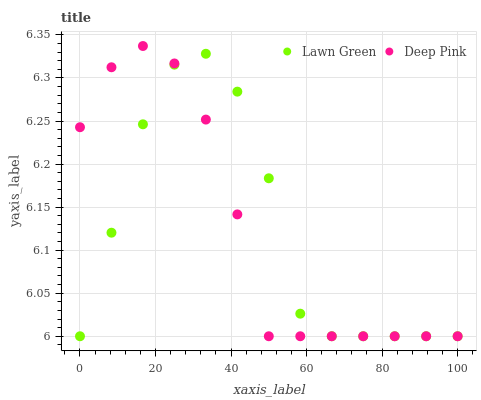Does Deep Pink have the minimum area under the curve?
Answer yes or no. Yes. Does Lawn Green have the maximum area under the curve?
Answer yes or no. Yes. Does Deep Pink have the maximum area under the curve?
Answer yes or no. No. Is Deep Pink the smoothest?
Answer yes or no. Yes. Is Lawn Green the roughest?
Answer yes or no. Yes. Is Deep Pink the roughest?
Answer yes or no. No. Does Lawn Green have the lowest value?
Answer yes or no. Yes. Does Deep Pink have the highest value?
Answer yes or no. Yes. Does Deep Pink intersect Lawn Green?
Answer yes or no. Yes. Is Deep Pink less than Lawn Green?
Answer yes or no. No. Is Deep Pink greater than Lawn Green?
Answer yes or no. No. 